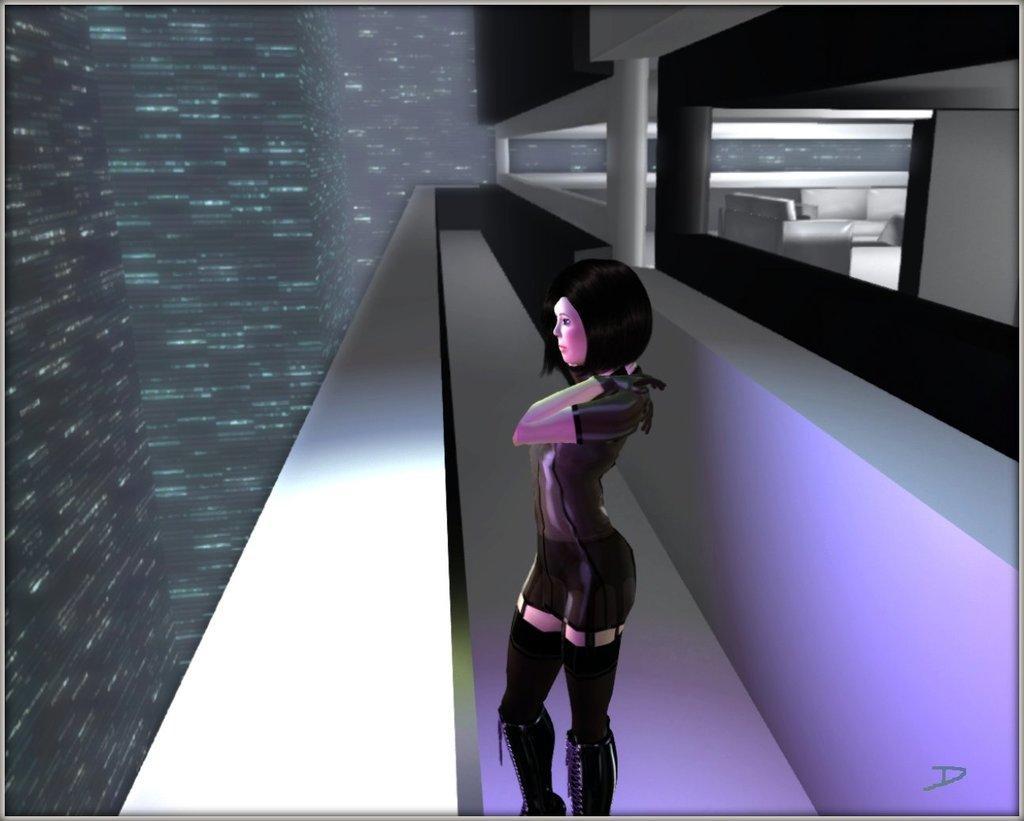Can you describe this image briefly? As we can see in the image there is an animation of building, a woman wearing black color dress and sofa. 